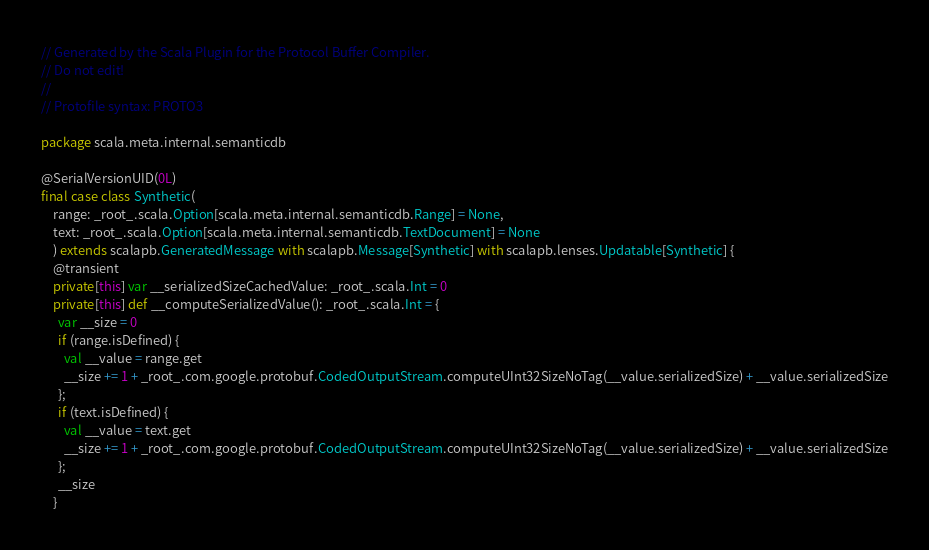Convert code to text. <code><loc_0><loc_0><loc_500><loc_500><_Scala_>// Generated by the Scala Plugin for the Protocol Buffer Compiler.
// Do not edit!
//
// Protofile syntax: PROTO3

package scala.meta.internal.semanticdb

@SerialVersionUID(0L)
final case class Synthetic(
    range: _root_.scala.Option[scala.meta.internal.semanticdb.Range] = None,
    text: _root_.scala.Option[scala.meta.internal.semanticdb.TextDocument] = None
    ) extends scalapb.GeneratedMessage with scalapb.Message[Synthetic] with scalapb.lenses.Updatable[Synthetic] {
    @transient
    private[this] var __serializedSizeCachedValue: _root_.scala.Int = 0
    private[this] def __computeSerializedValue(): _root_.scala.Int = {
      var __size = 0
      if (range.isDefined) {
        val __value = range.get
        __size += 1 + _root_.com.google.protobuf.CodedOutputStream.computeUInt32SizeNoTag(__value.serializedSize) + __value.serializedSize
      };
      if (text.isDefined) {
        val __value = text.get
        __size += 1 + _root_.com.google.protobuf.CodedOutputStream.computeUInt32SizeNoTag(__value.serializedSize) + __value.serializedSize
      };
      __size
    }</code> 